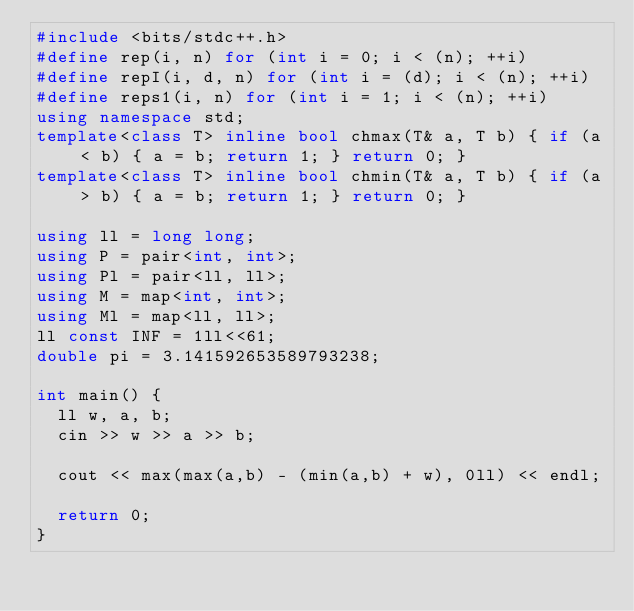Convert code to text. <code><loc_0><loc_0><loc_500><loc_500><_C++_>#include <bits/stdc++.h>
#define rep(i, n) for (int i = 0; i < (n); ++i)
#define repI(i, d, n) for (int i = (d); i < (n); ++i)
#define reps1(i, n) for (int i = 1; i < (n); ++i)
using namespace std;
template<class T> inline bool chmax(T& a, T b) { if (a < b) { a = b; return 1; } return 0; }
template<class T> inline bool chmin(T& a, T b) { if (a > b) { a = b; return 1; } return 0; }

using ll = long long;
using P = pair<int, int>;
using Pl = pair<ll, ll>;
using M = map<int, int>;
using Ml = map<ll, ll>;
ll const INF = 1ll<<61;
double pi = 3.141592653589793238;

int main() {
  ll w, a, b;
  cin >> w >> a >> b;

  cout << max(max(a,b) - (min(a,b) + w), 0ll) << endl;

  return 0;
}
</code> 